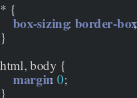<code> <loc_0><loc_0><loc_500><loc_500><_CSS_>* {
    box-sizing: border-box;
}

html, body {
    margin: 0;
}
</code> 